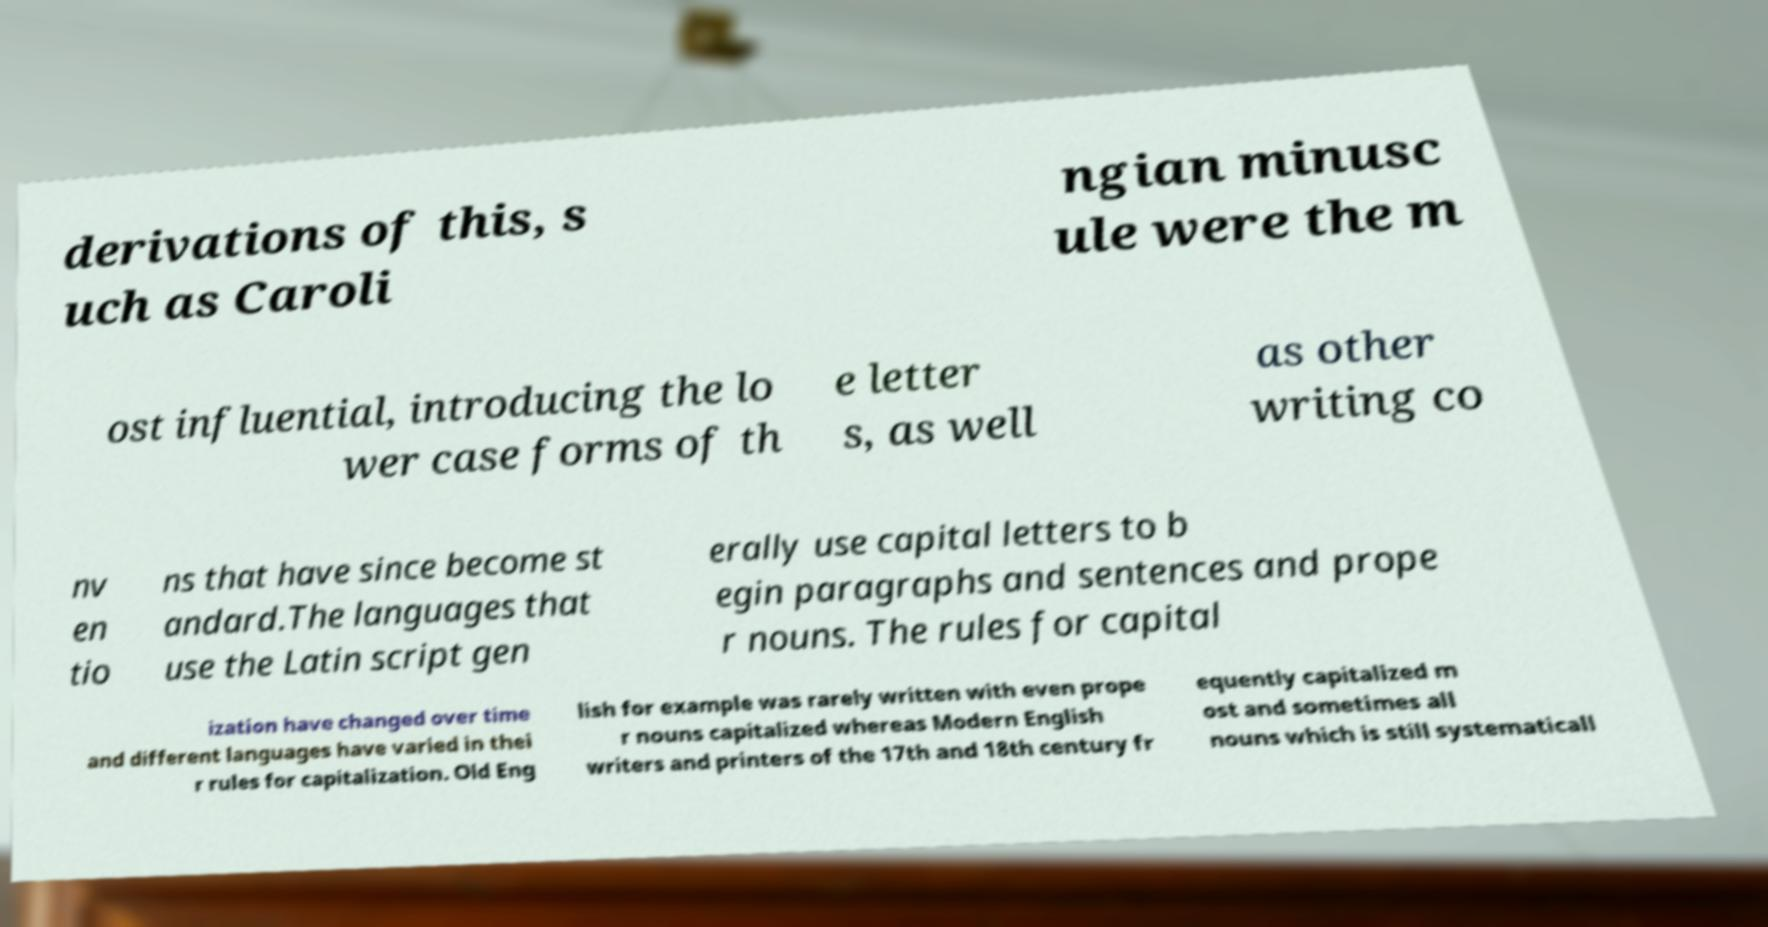Can you accurately transcribe the text from the provided image for me? derivations of this, s uch as Caroli ngian minusc ule were the m ost influential, introducing the lo wer case forms of th e letter s, as well as other writing co nv en tio ns that have since become st andard.The languages that use the Latin script gen erally use capital letters to b egin paragraphs and sentences and prope r nouns. The rules for capital ization have changed over time and different languages have varied in thei r rules for capitalization. Old Eng lish for example was rarely written with even prope r nouns capitalized whereas Modern English writers and printers of the 17th and 18th century fr equently capitalized m ost and sometimes all nouns which is still systematicall 